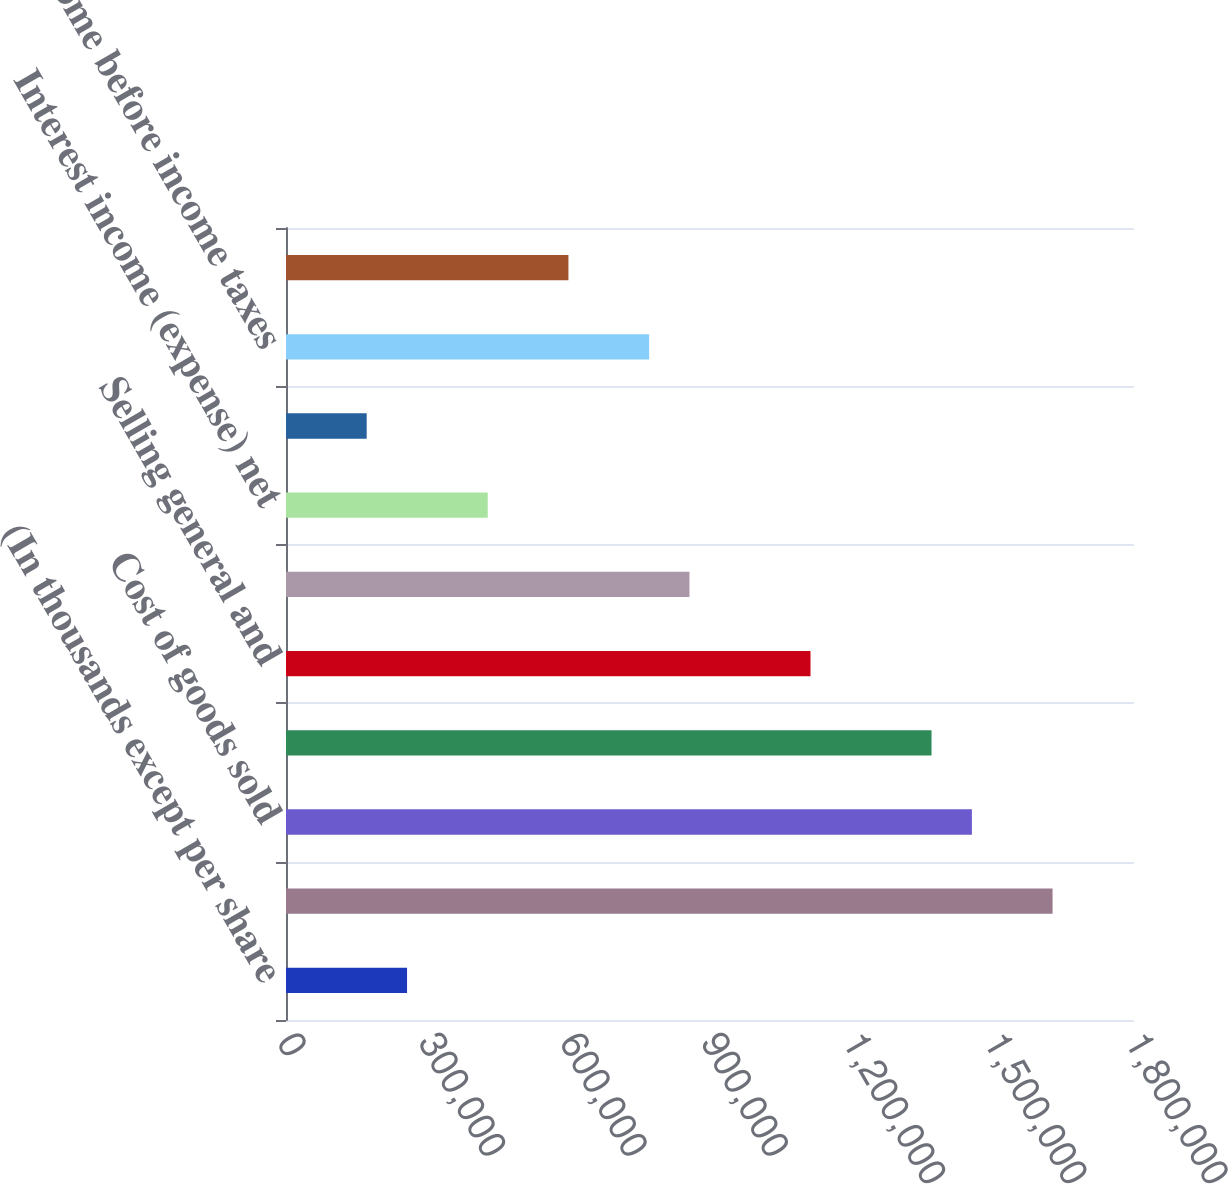<chart> <loc_0><loc_0><loc_500><loc_500><bar_chart><fcel>(In thousands except per share<fcel>Net revenues<fcel>Cost of goods sold<fcel>Gross profit<fcel>Selling general and<fcel>Income from operations<fcel>Interest income (expense) net<fcel>Other income (expense) net<fcel>Income before income taxes<fcel>Provision for income taxes<nl><fcel>256924<fcel>1.62718e+06<fcel>1.4559e+06<fcel>1.37026e+06<fcel>1.11333e+06<fcel>856411<fcel>428206<fcel>171283<fcel>770770<fcel>599488<nl></chart> 